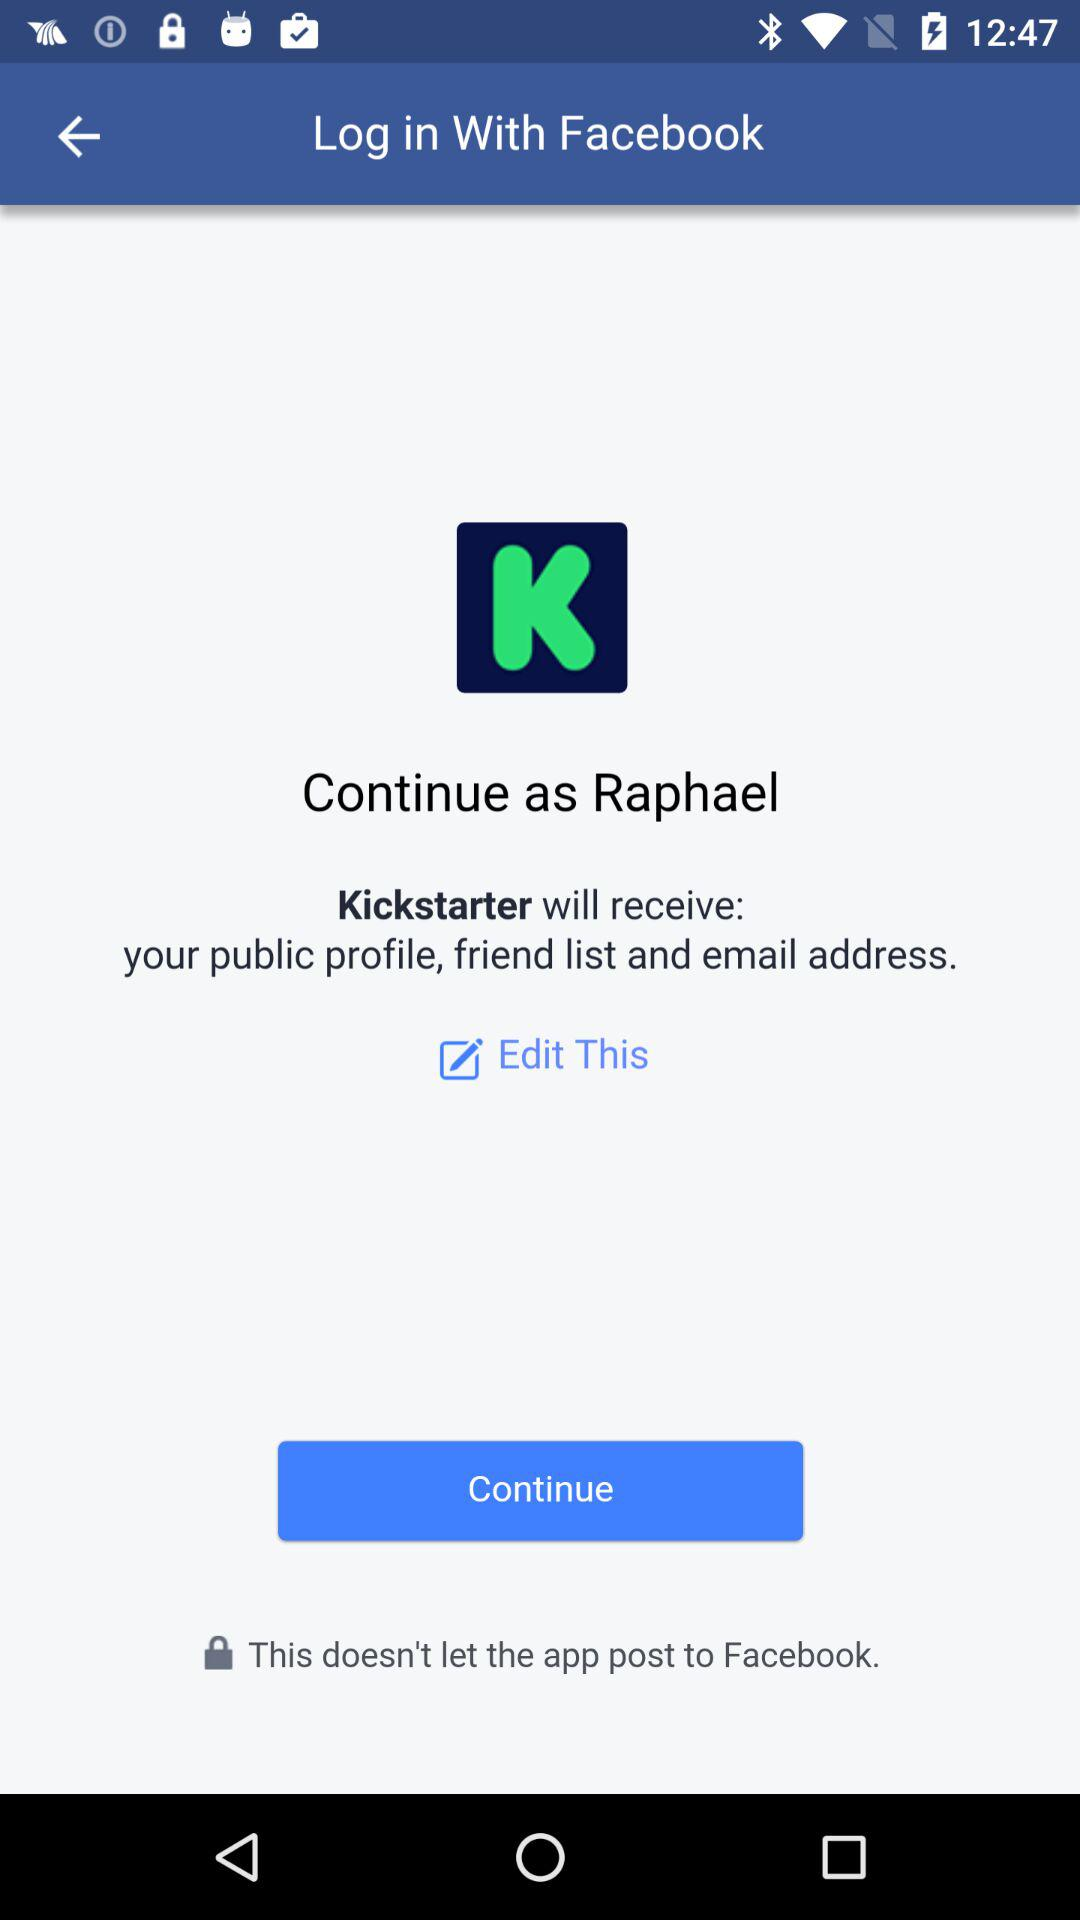What is the user name? The user name is Raphael. 